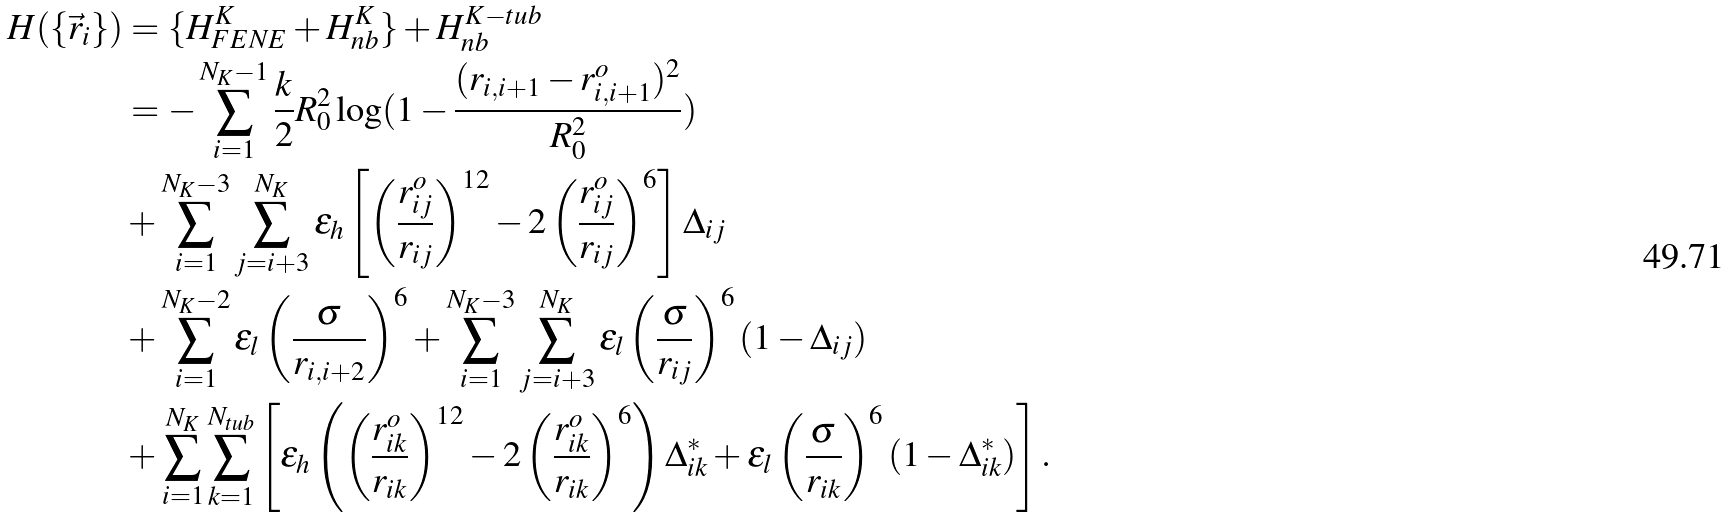Convert formula to latex. <formula><loc_0><loc_0><loc_500><loc_500>H ( \{ \vec { r } _ { i } \} ) & = \{ H ^ { K } _ { F E N E } + H ^ { K } _ { n b } \} + H ^ { K - t u b } _ { n b } \\ & = - \sum _ { i = 1 } ^ { N _ { K } - 1 } \frac { k } { 2 } R _ { 0 } ^ { 2 } \log ( { 1 - \frac { ( r _ { i , i + 1 } - r _ { i , i + 1 } ^ { o } ) ^ { 2 } } { R _ { 0 } ^ { 2 } } } ) \\ & + \sum _ { i = 1 } ^ { N _ { K } - 3 } \sum _ { j = i + 3 } ^ { N _ { K } } \epsilon _ { h } \left [ \left ( \frac { r ^ { o } _ { i j } } { r _ { i j } } \right ) ^ { 1 2 } - 2 \left ( \frac { r ^ { o } _ { i j } } { r _ { i j } } \right ) ^ { 6 } \right ] \Delta _ { i j } \\ & + \sum _ { i = 1 } ^ { N _ { K } - 2 } \epsilon _ { l } \left ( \frac { \sigma } { r _ { i , i + 2 } } \right ) ^ { 6 } + \sum _ { i = 1 } ^ { N _ { K } - 3 } \sum _ { j = i + 3 } ^ { N _ { K } } \epsilon _ { l } \left ( \frac { \sigma } { r _ { i j } } \right ) ^ { 6 } ( 1 - \Delta _ { i j } ) \\ & + \sum _ { i = 1 } ^ { N _ { K } } \sum _ { k = 1 } ^ { N _ { t u b } } \left [ \epsilon _ { h } \left ( \left ( \frac { r ^ { o } _ { i k } } { r _ { i k } } \right ) ^ { 1 2 } - 2 \left ( \frac { r ^ { o } _ { i k } } { r _ { i k } } \right ) ^ { 6 } \right ) \Delta ^ { * } _ { i k } + \epsilon _ { l } \left ( \frac { \sigma } { r _ { i k } } \right ) ^ { 6 } ( 1 - \Delta ^ { * } _ { i k } ) \right ] .</formula> 